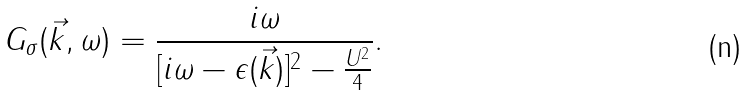Convert formula to latex. <formula><loc_0><loc_0><loc_500><loc_500>G _ { \sigma } ( \vec { k } , \omega ) = \frac { i \omega } { [ i \omega - \epsilon ( \vec { k } ) ] ^ { 2 } - \frac { U ^ { 2 } } { 4 } } .</formula> 